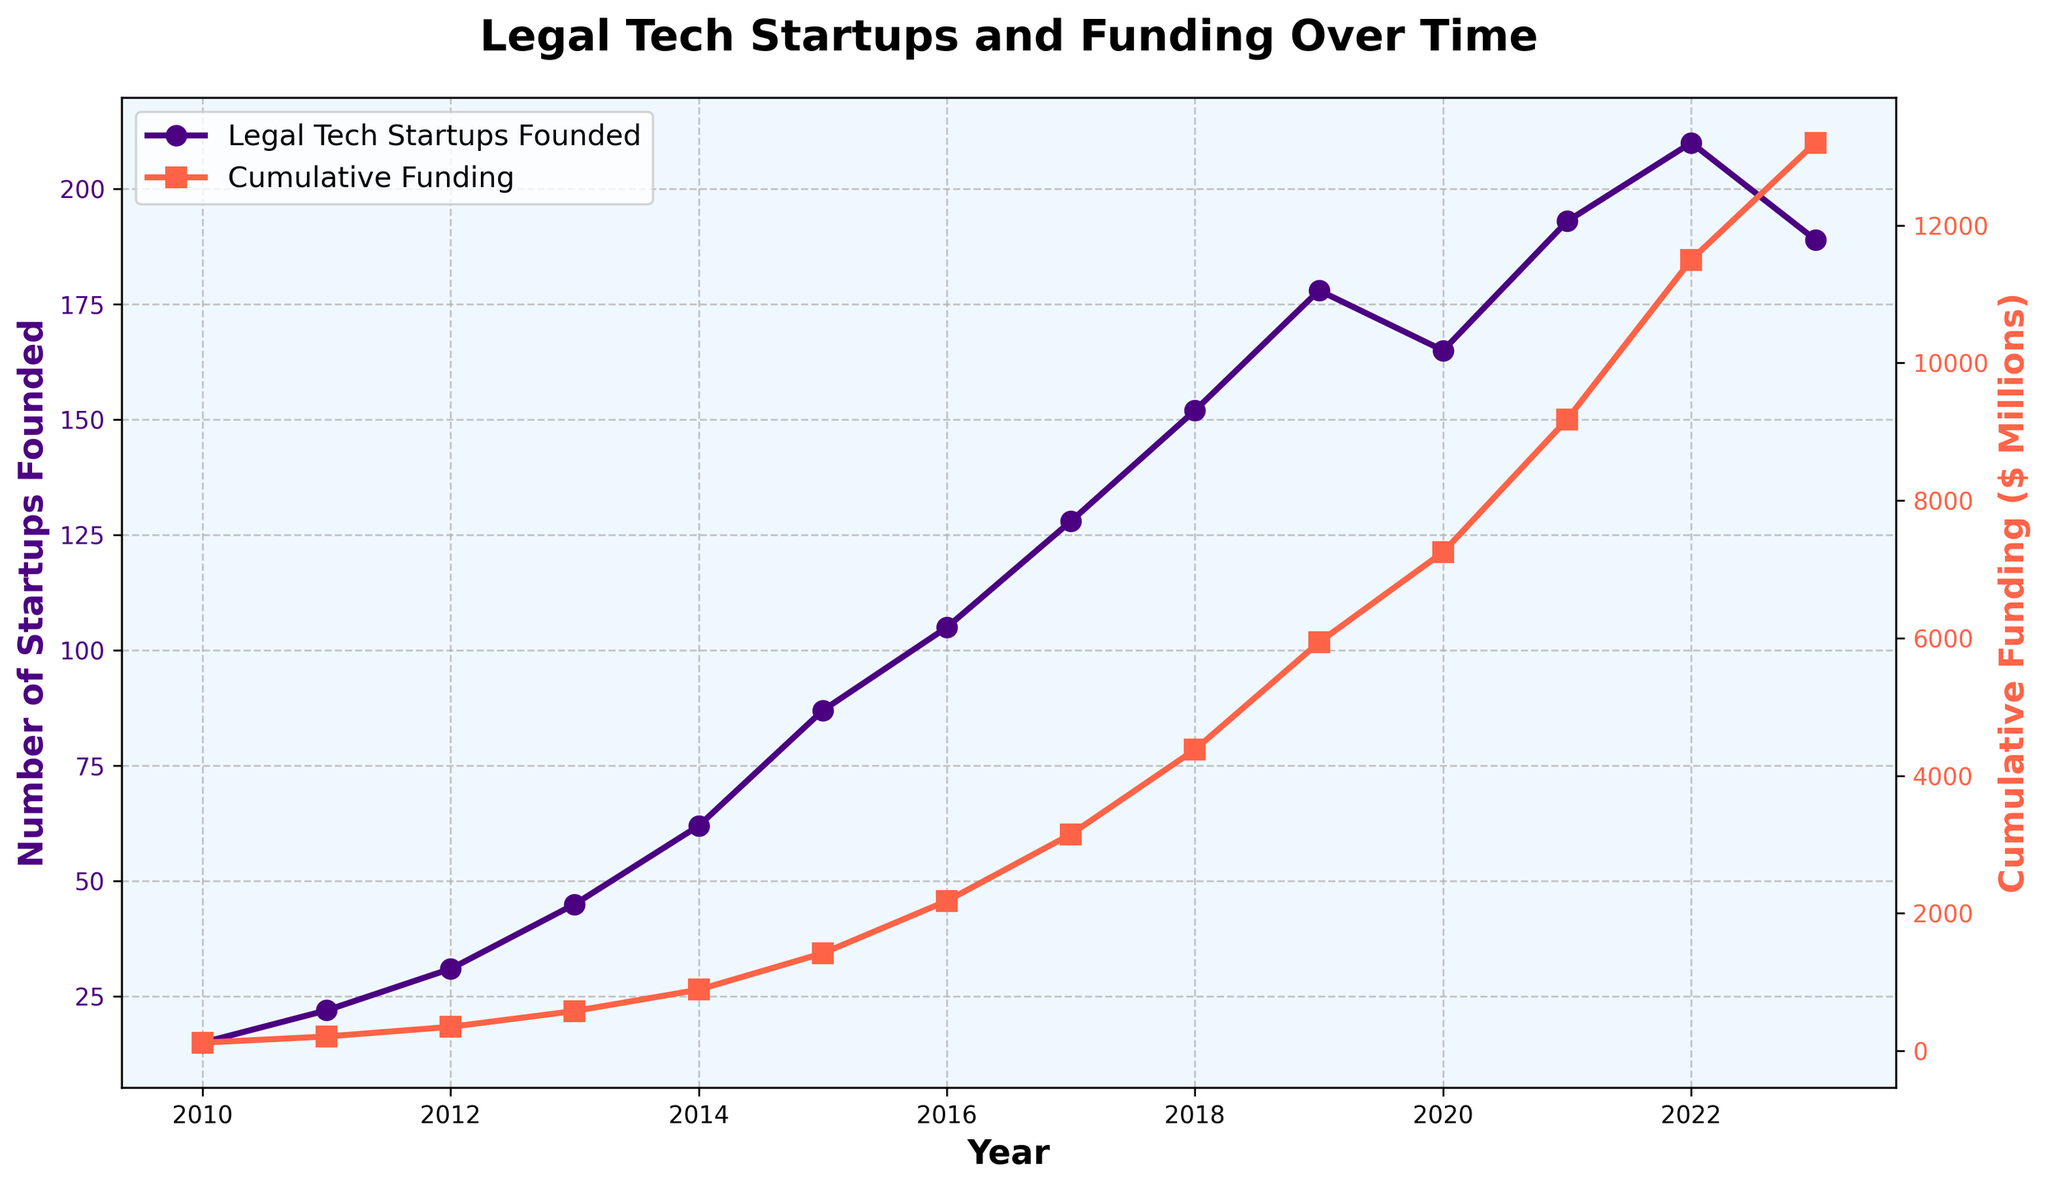How many legal tech startups were founded in 2015, and what was the cumulative funding that year? Look at the data points for the year 2015. The number of startups founded is 87, and the cumulative funding is $1420 million.
Answer: 87 startups, $1420 million By how much did the cumulative funding increase from 2017 to 2018? Find the cumulative funding for 2017 ($3150 million) and for 2018 ($4380 million). Subtract the 2017 value from the 2018 value: $4380 million - $3150 million = $1230 million.
Answer: $1230 million Which year saw the highest number of legal tech startups being founded? Identify the highest point on the "Legal Tech Startups Founded" line, which occurs in 2022 with 210 startups founded.
Answer: 2022 Compare the cumulative funding between 2020 and 2021. Which year had a higher funding amount? Look at the data points and identify the cumulative funding for 2020 ($7250 million) and for 2021 ($9180 million). 2021 has the higher funding amount.
Answer: 2021 What is the average number of legal tech startups founded from 2010 to 2013? Sum the number of startups from 2010 to 2013 (15 + 22 + 31 + 45) = 113. Then divide by the number of years (4): 113 / 4 = 28.25.
Answer: 28.25 In which year did cumulative funding first exceed $5000 million? Check the data points to see when the cumulative funding surpassed $5000 million. In 2019, the funding is $5940 million, which is the first year it surpasses $5000 million.
Answer: 2019 Identify the sharpest increase in the number of legal tech startups founded in a single year. Calculate the difference in the number of startups founded year-over-year and identify the largest increase. The largest increase is from 2014 to 2015 (87 - 62 = 25 startups).
Answer: 2014 to 2015 Which color represents the cumulative funding line on the graph? The graph uses color to differentiate lines. The cumulative funding line is represented by the red line with square markers.
Answer: Red How does the number of legal tech startups founded in 2023 compare to 2022? Compare the data points for 2023 (189 startups) and 2022 (210 startups). The number of startups in 2023 is lower than in 2022.
Answer: 2023 is lower What was the cumulative funding in the first year recorded on the chart? Look at the data point for 2010 to find the cumulative funding, which is $120 million.
Answer: $120 million 